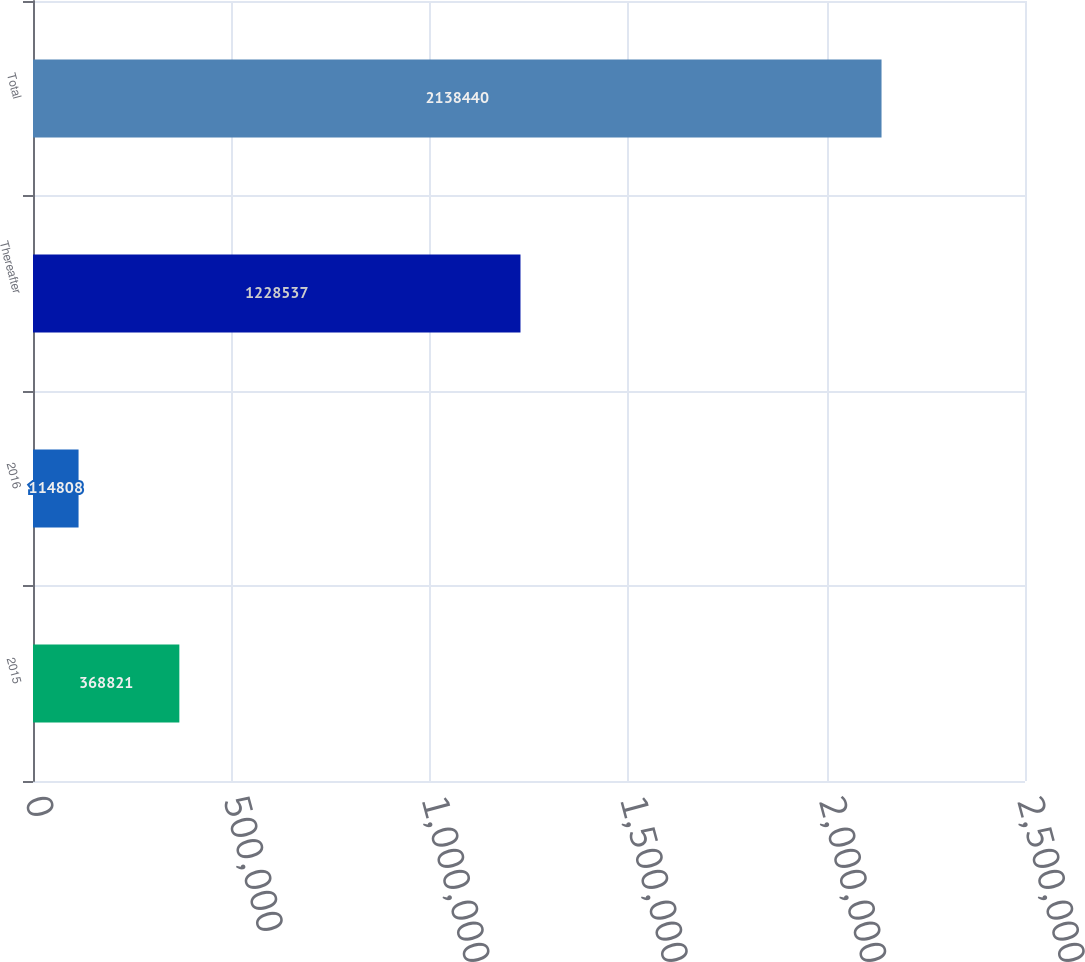Convert chart to OTSL. <chart><loc_0><loc_0><loc_500><loc_500><bar_chart><fcel>2015<fcel>2016<fcel>Thereafter<fcel>Total<nl><fcel>368821<fcel>114808<fcel>1.22854e+06<fcel>2.13844e+06<nl></chart> 